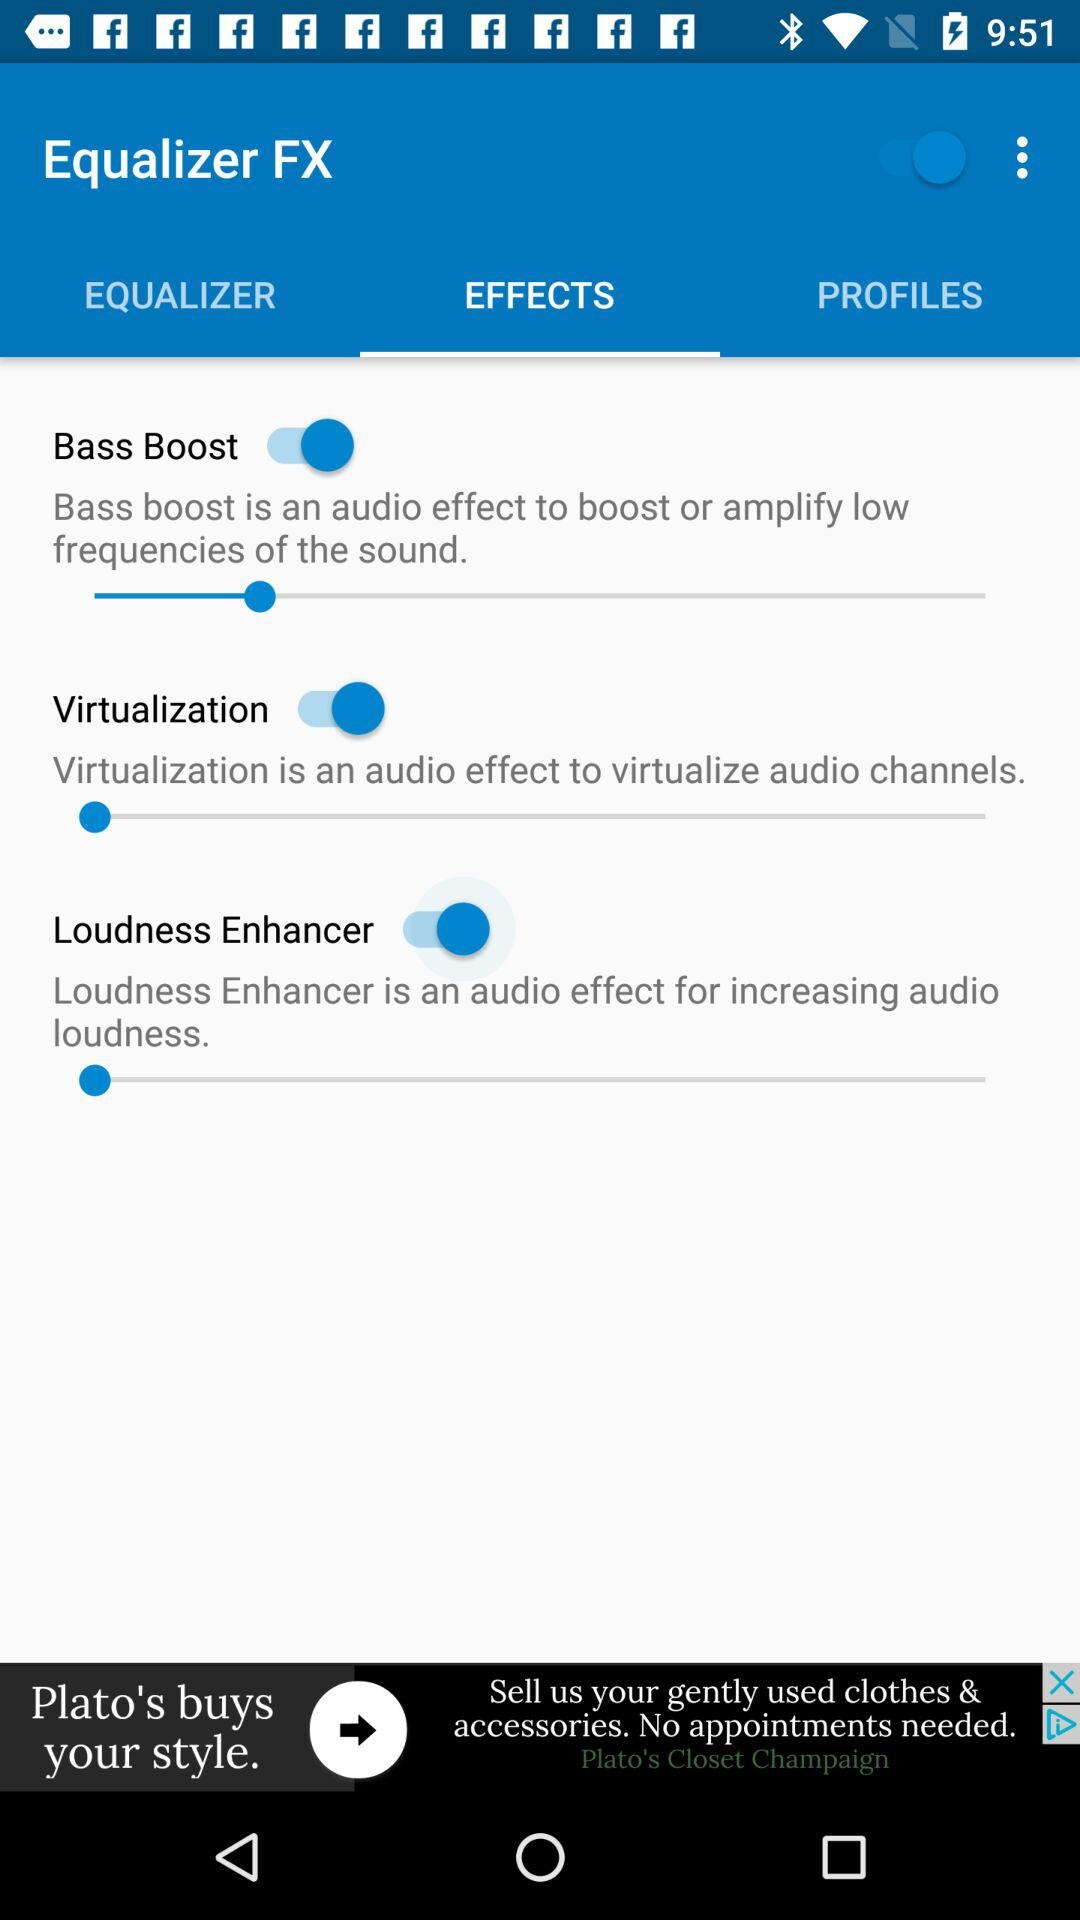What is the application name? The application name is "Equalizer FX". 